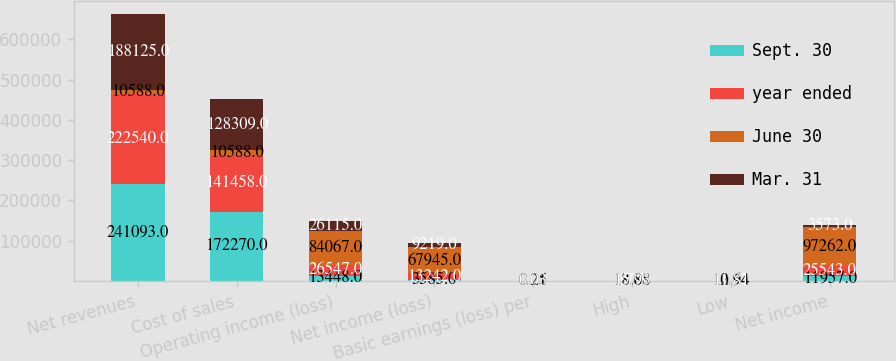Convert chart. <chart><loc_0><loc_0><loc_500><loc_500><stacked_bar_chart><ecel><fcel>Net revenues<fcel>Cost of sales<fcel>Operating income (loss)<fcel>Net income (loss)<fcel>Basic earnings (loss) per<fcel>High<fcel>Low<fcel>Net income<nl><fcel>Sept. 30<fcel>241093<fcel>172270<fcel>13448<fcel>3585<fcel>0.01<fcel>13.88<fcel>10.64<fcel>11957<nl><fcel>year ended<fcel>222540<fcel>141458<fcel>26547<fcel>13242<fcel>0.05<fcel>17.3<fcel>12.07<fcel>25543<nl><fcel>June 30<fcel>10588<fcel>10588<fcel>84067<fcel>67945<fcel>0.25<fcel>18.03<fcel>12.94<fcel>97262<nl><fcel>Mar. 31<fcel>188125<fcel>128309<fcel>26115<fcel>9219<fcel>0.03<fcel>15.93<fcel>11.81<fcel>3573<nl></chart> 